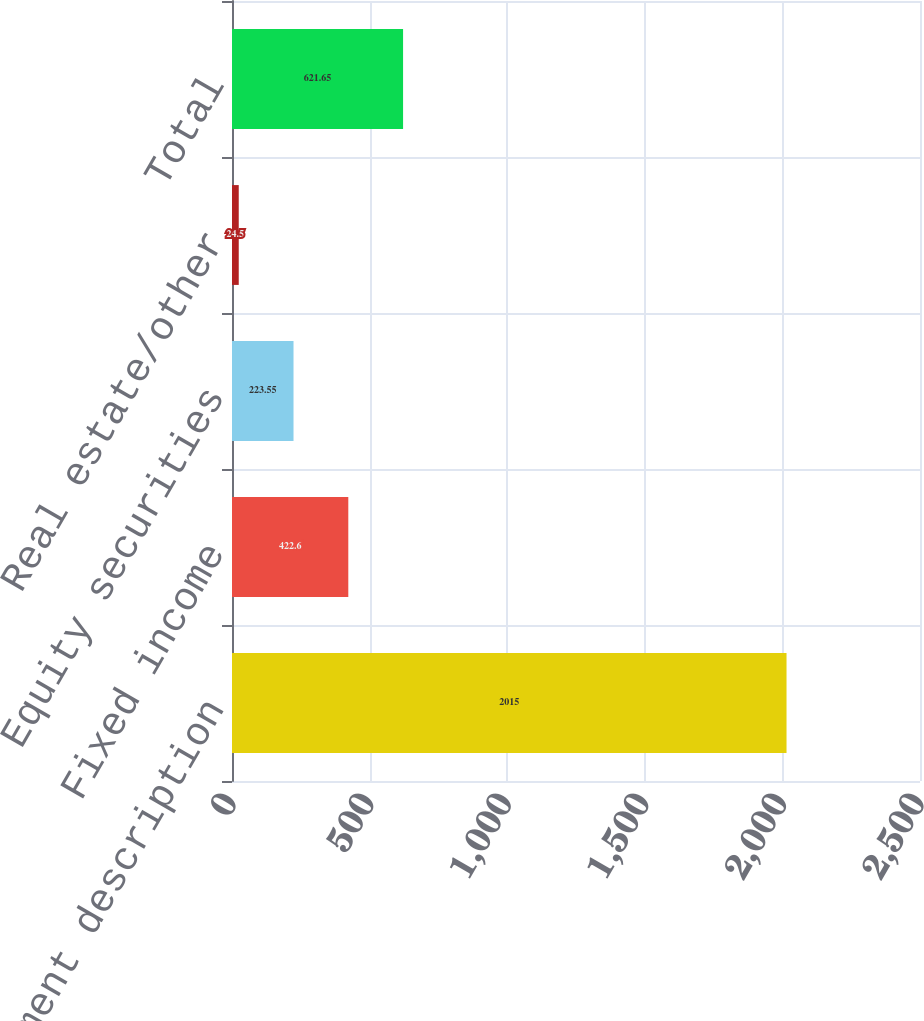<chart> <loc_0><loc_0><loc_500><loc_500><bar_chart><fcel>Investment description<fcel>Fixed income<fcel>Equity securities<fcel>Real estate/other<fcel>Total<nl><fcel>2015<fcel>422.6<fcel>223.55<fcel>24.5<fcel>621.65<nl></chart> 